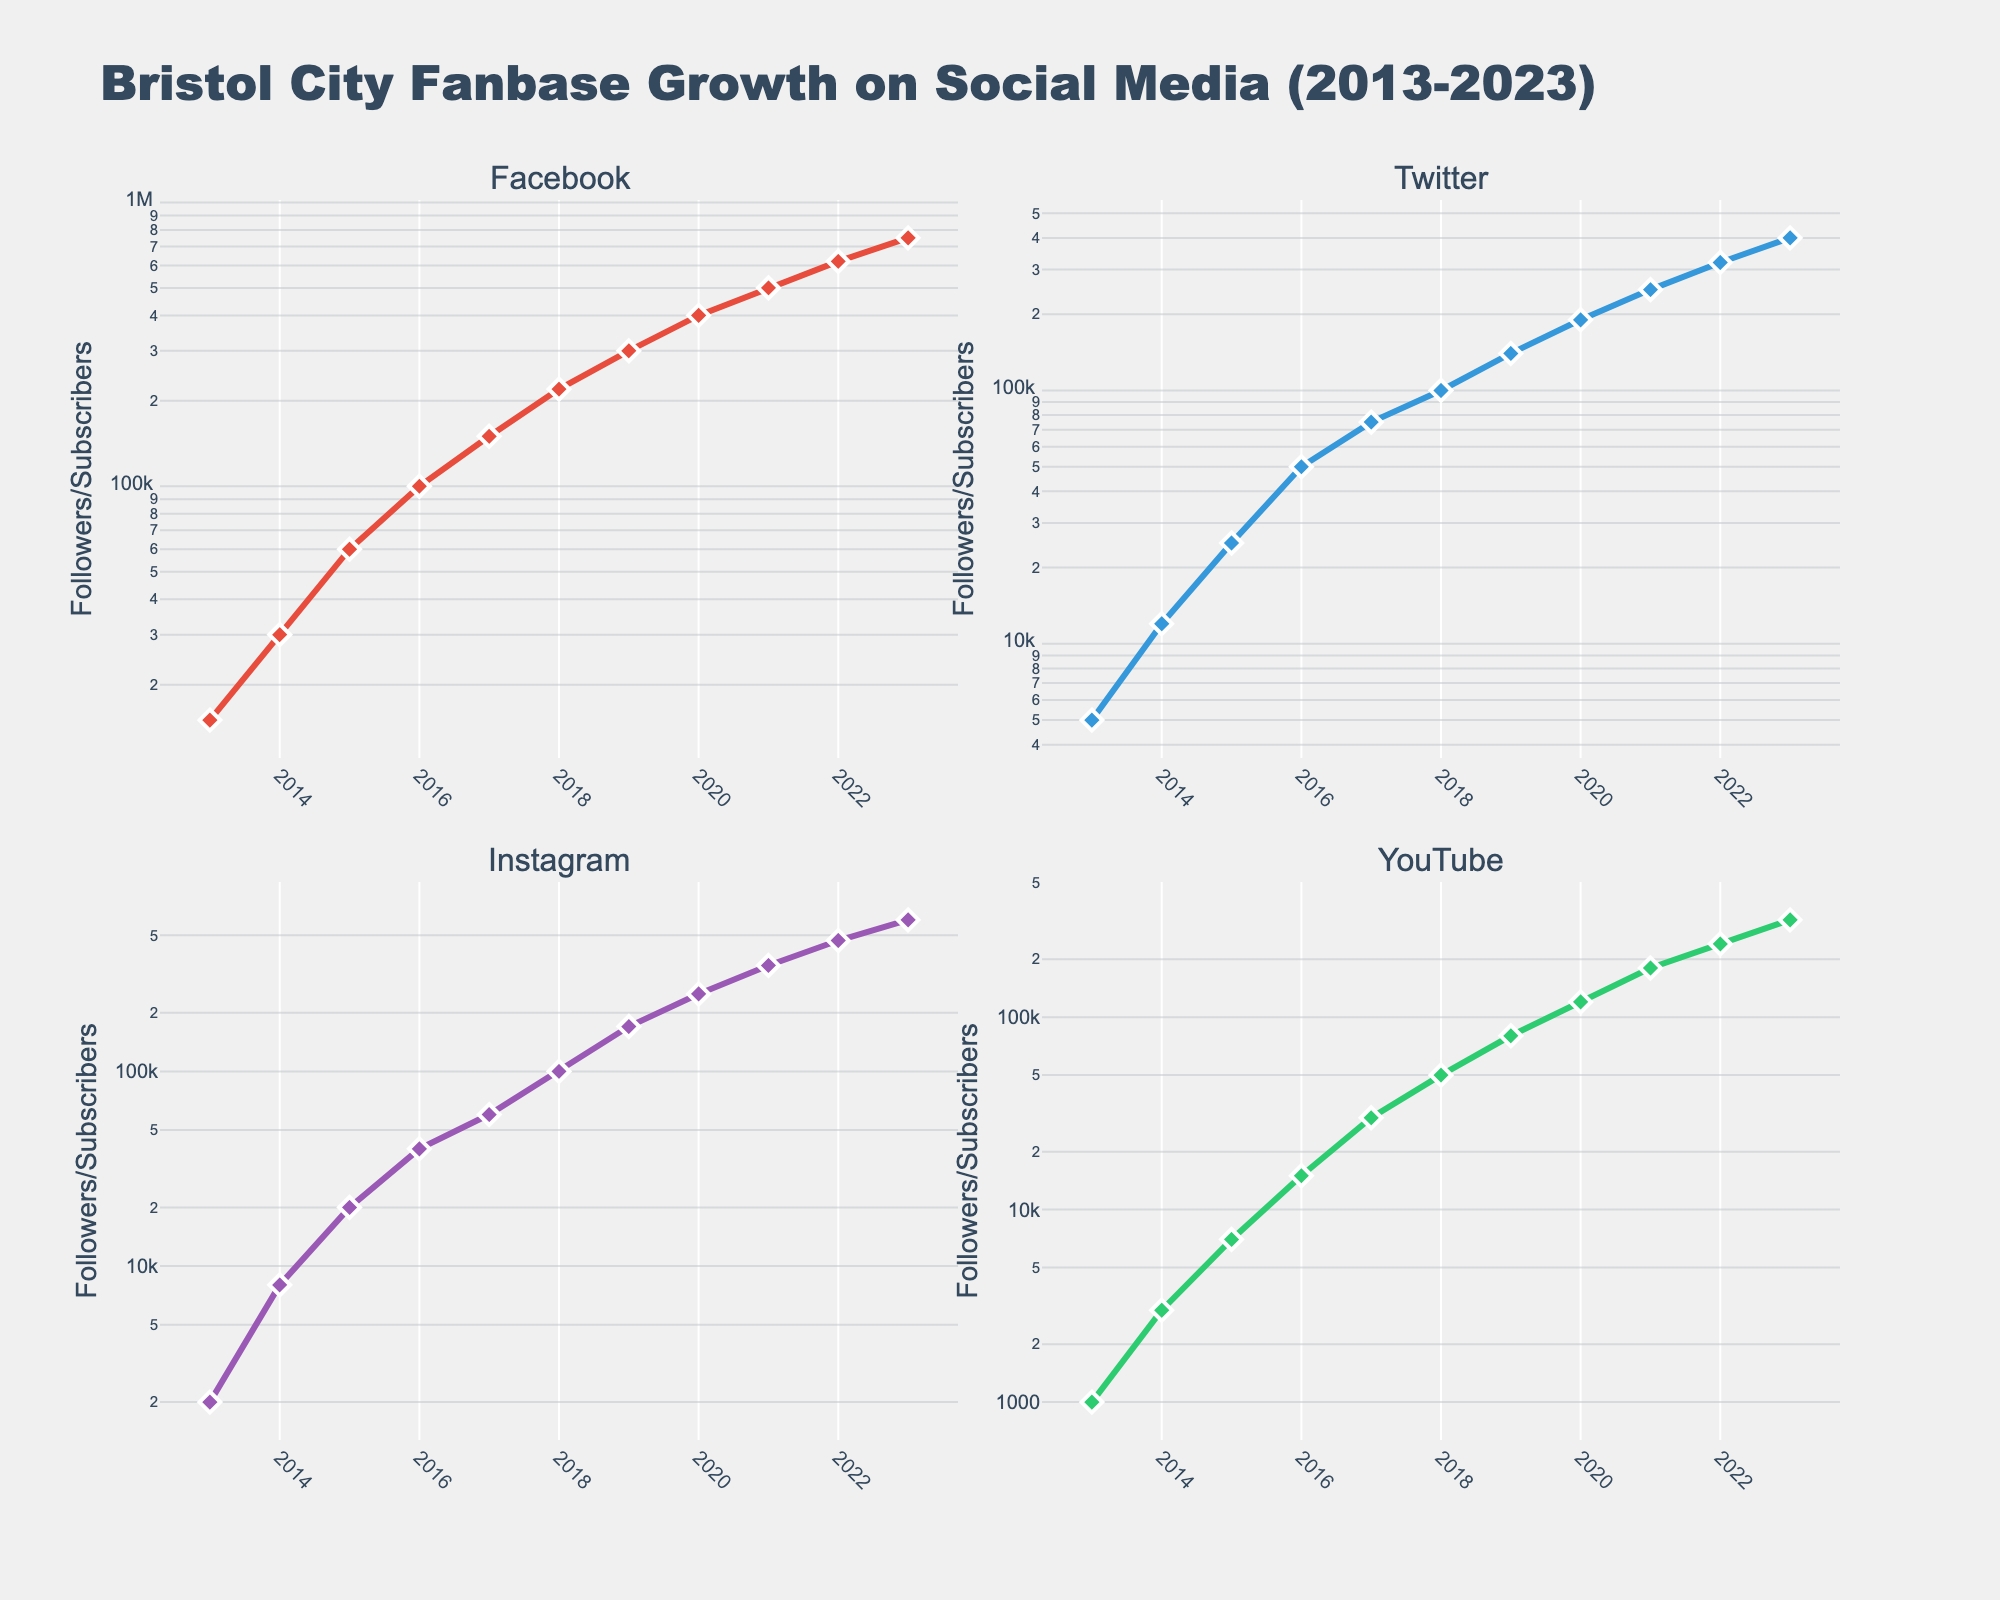What's the title of the figure? The title of the figure is located at the top of the chart. It reads "Bristol City Fanbase Growth on Social Media (2013-2023)".
Answer: Bristol City Fanbase Growth on Social Media (2013-2023) Which social media platform had the highest number of followers/subscribers in 2023? To find this, look at the figures in each subplot for the year 2023. Facebook Followers has the highest value around 750,000.
Answer: Facebook What is the y-axis scale used in the subplots? By observing the y-axis and its labeling, it's evident that the axis follows a logarithmic scale, indicated by the exponential growth pattern.
Answer: Logarithmic scale In 2023, which platform saw the biggest growth in followers/subscribers compared to 2013? Calculate the growth by subtracting the 2013 values from the 2023 values for each platform. Facebook increased by 735,000 (750,000 - 15,000). For others: Twitter (395,000), Instagram (598,000), YouTube (319,000). Facebook had the biggest growth.
Answer: Facebook What trend can be observed across all platforms between 2013 and 2023? A consistent increase in the number of followers/subscribers is observed across all platforms, suggesting a growing fanbase over the decade.
Answer: Consistent increase Which year approximately did Twitter Followers reach 100,000? Locate the data point where Twitter Followers reach 100,000 on its subplot. This occurs near the year 2018.
Answer: 2018 What is the approximate number of YouTube Subscribers in 2015? Check the value on the YouTube subplot for the year 2015. The value is around 7,000.
Answer: 7,000 Between 2015 and 2020, which platform had the most significant relative change in followers/subscribers? Calculate the percentage increase for each platform from 2015 to 2020. Facebook: (400,000-60,000)/60,000 = 566.67%. Twitter: (190,000-25,000)/25,000 = 660%. Instagram: (250,000-20,000)/20,000 = 1150%. YouTube: (120,000-7,000)/7,000 = 1614.29%. YouTube had the most significant relative change.
Answer: YouTube Which platform shows the steepest growth trend in their respective subplot? By comparing the slopes of the lines on the log scale, Instagram shows the steepest growth, suggesting a higher rate of follower acquisition over time.
Answer: Instagram Are there any platforms where growth stagnated over any period? Observing the trends for all subplots, none of the platforms show stagnation; all present consistent growth each year.
Answer: No 